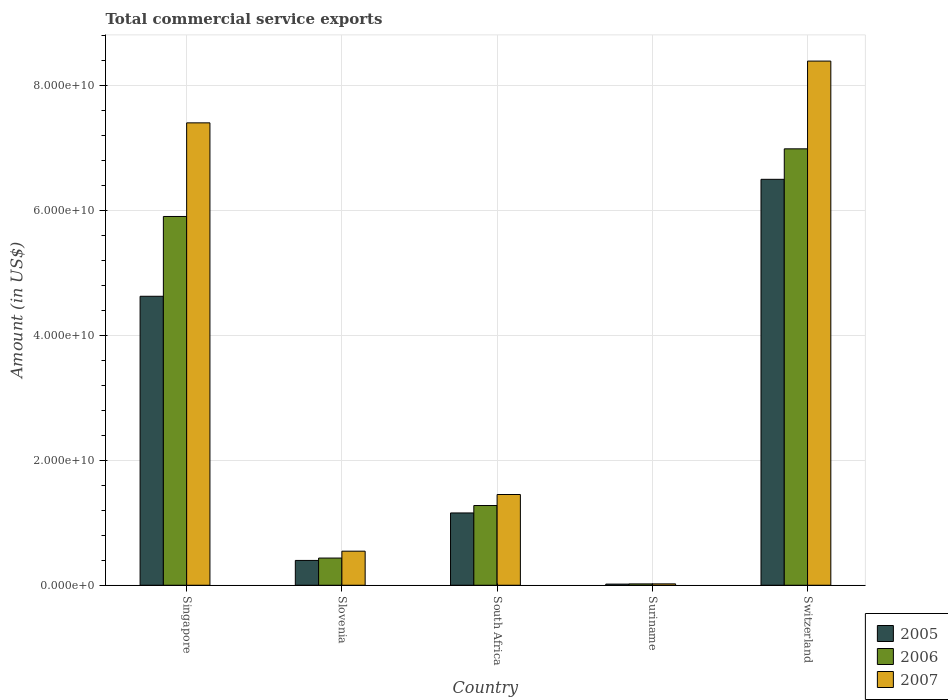How many different coloured bars are there?
Your response must be concise. 3. Are the number of bars per tick equal to the number of legend labels?
Keep it short and to the point. Yes. Are the number of bars on each tick of the X-axis equal?
Make the answer very short. Yes. How many bars are there on the 5th tick from the right?
Offer a terse response. 3. What is the label of the 3rd group of bars from the left?
Make the answer very short. South Africa. In how many cases, is the number of bars for a given country not equal to the number of legend labels?
Provide a succinct answer. 0. What is the total commercial service exports in 2006 in Singapore?
Give a very brief answer. 5.90e+1. Across all countries, what is the maximum total commercial service exports in 2006?
Keep it short and to the point. 6.98e+1. Across all countries, what is the minimum total commercial service exports in 2007?
Give a very brief answer. 2.19e+08. In which country was the total commercial service exports in 2007 maximum?
Provide a short and direct response. Switzerland. In which country was the total commercial service exports in 2007 minimum?
Give a very brief answer. Suriname. What is the total total commercial service exports in 2007 in the graph?
Offer a very short reply. 1.78e+11. What is the difference between the total commercial service exports in 2006 in Slovenia and that in Suriname?
Provide a short and direct response. 4.14e+09. What is the difference between the total commercial service exports in 2005 in Singapore and the total commercial service exports in 2006 in Suriname?
Give a very brief answer. 4.60e+1. What is the average total commercial service exports in 2006 per country?
Ensure brevity in your answer.  2.92e+1. What is the difference between the total commercial service exports of/in 2005 and total commercial service exports of/in 2007 in Suriname?
Make the answer very short. -3.61e+07. What is the ratio of the total commercial service exports in 2005 in Suriname to that in Switzerland?
Make the answer very short. 0. Is the total commercial service exports in 2006 in South Africa less than that in Suriname?
Provide a short and direct response. No. What is the difference between the highest and the second highest total commercial service exports in 2007?
Your answer should be compact. -6.94e+1. What is the difference between the highest and the lowest total commercial service exports in 2005?
Provide a succinct answer. 6.48e+1. In how many countries, is the total commercial service exports in 2007 greater than the average total commercial service exports in 2007 taken over all countries?
Offer a terse response. 2. Is it the case that in every country, the sum of the total commercial service exports in 2005 and total commercial service exports in 2007 is greater than the total commercial service exports in 2006?
Offer a very short reply. Yes. How many countries are there in the graph?
Ensure brevity in your answer.  5. Are the values on the major ticks of Y-axis written in scientific E-notation?
Offer a very short reply. Yes. Does the graph contain any zero values?
Your answer should be very brief. No. How are the legend labels stacked?
Offer a very short reply. Vertical. What is the title of the graph?
Keep it short and to the point. Total commercial service exports. Does "1998" appear as one of the legend labels in the graph?
Your answer should be very brief. No. What is the Amount (in US$) of 2005 in Singapore?
Ensure brevity in your answer.  4.62e+1. What is the Amount (in US$) of 2006 in Singapore?
Offer a terse response. 5.90e+1. What is the Amount (in US$) in 2007 in Singapore?
Your answer should be compact. 7.40e+1. What is the Amount (in US$) in 2005 in Slovenia?
Offer a very short reply. 3.97e+09. What is the Amount (in US$) in 2006 in Slovenia?
Provide a short and direct response. 4.35e+09. What is the Amount (in US$) of 2007 in Slovenia?
Your answer should be compact. 5.45e+09. What is the Amount (in US$) of 2005 in South Africa?
Ensure brevity in your answer.  1.16e+1. What is the Amount (in US$) in 2006 in South Africa?
Your response must be concise. 1.28e+1. What is the Amount (in US$) of 2007 in South Africa?
Your response must be concise. 1.45e+1. What is the Amount (in US$) in 2005 in Suriname?
Make the answer very short. 1.83e+08. What is the Amount (in US$) of 2006 in Suriname?
Provide a succinct answer. 2.14e+08. What is the Amount (in US$) in 2007 in Suriname?
Your response must be concise. 2.19e+08. What is the Amount (in US$) of 2005 in Switzerland?
Provide a short and direct response. 6.50e+1. What is the Amount (in US$) in 2006 in Switzerland?
Your answer should be compact. 6.98e+1. What is the Amount (in US$) in 2007 in Switzerland?
Provide a succinct answer. 8.39e+1. Across all countries, what is the maximum Amount (in US$) of 2005?
Provide a succinct answer. 6.50e+1. Across all countries, what is the maximum Amount (in US$) of 2006?
Your answer should be compact. 6.98e+1. Across all countries, what is the maximum Amount (in US$) in 2007?
Your answer should be very brief. 8.39e+1. Across all countries, what is the minimum Amount (in US$) in 2005?
Provide a short and direct response. 1.83e+08. Across all countries, what is the minimum Amount (in US$) of 2006?
Ensure brevity in your answer.  2.14e+08. Across all countries, what is the minimum Amount (in US$) in 2007?
Make the answer very short. 2.19e+08. What is the total Amount (in US$) of 2005 in the graph?
Offer a terse response. 1.27e+11. What is the total Amount (in US$) in 2006 in the graph?
Provide a short and direct response. 1.46e+11. What is the total Amount (in US$) of 2007 in the graph?
Offer a very short reply. 1.78e+11. What is the difference between the Amount (in US$) of 2005 in Singapore and that in Slovenia?
Your answer should be very brief. 4.23e+1. What is the difference between the Amount (in US$) of 2006 in Singapore and that in Slovenia?
Offer a very short reply. 5.47e+1. What is the difference between the Amount (in US$) in 2007 in Singapore and that in Slovenia?
Provide a short and direct response. 6.85e+1. What is the difference between the Amount (in US$) in 2005 in Singapore and that in South Africa?
Your answer should be compact. 3.47e+1. What is the difference between the Amount (in US$) of 2006 in Singapore and that in South Africa?
Make the answer very short. 4.63e+1. What is the difference between the Amount (in US$) of 2007 in Singapore and that in South Africa?
Keep it short and to the point. 5.95e+1. What is the difference between the Amount (in US$) of 2005 in Singapore and that in Suriname?
Offer a terse response. 4.61e+1. What is the difference between the Amount (in US$) of 2006 in Singapore and that in Suriname?
Offer a terse response. 5.88e+1. What is the difference between the Amount (in US$) in 2007 in Singapore and that in Suriname?
Provide a succinct answer. 7.38e+1. What is the difference between the Amount (in US$) of 2005 in Singapore and that in Switzerland?
Your answer should be compact. -1.87e+1. What is the difference between the Amount (in US$) of 2006 in Singapore and that in Switzerland?
Your answer should be compact. -1.08e+1. What is the difference between the Amount (in US$) of 2007 in Singapore and that in Switzerland?
Your response must be concise. -9.89e+09. What is the difference between the Amount (in US$) of 2005 in Slovenia and that in South Africa?
Make the answer very short. -7.60e+09. What is the difference between the Amount (in US$) of 2006 in Slovenia and that in South Africa?
Your answer should be compact. -8.41e+09. What is the difference between the Amount (in US$) in 2007 in Slovenia and that in South Africa?
Make the answer very short. -9.07e+09. What is the difference between the Amount (in US$) of 2005 in Slovenia and that in Suriname?
Your response must be concise. 3.79e+09. What is the difference between the Amount (in US$) in 2006 in Slovenia and that in Suriname?
Provide a succinct answer. 4.14e+09. What is the difference between the Amount (in US$) in 2007 in Slovenia and that in Suriname?
Give a very brief answer. 5.23e+09. What is the difference between the Amount (in US$) in 2005 in Slovenia and that in Switzerland?
Your response must be concise. -6.10e+1. What is the difference between the Amount (in US$) of 2006 in Slovenia and that in Switzerland?
Offer a very short reply. -6.55e+1. What is the difference between the Amount (in US$) of 2007 in Slovenia and that in Switzerland?
Make the answer very short. -7.84e+1. What is the difference between the Amount (in US$) of 2005 in South Africa and that in Suriname?
Give a very brief answer. 1.14e+1. What is the difference between the Amount (in US$) of 2006 in South Africa and that in Suriname?
Give a very brief answer. 1.25e+1. What is the difference between the Amount (in US$) in 2007 in South Africa and that in Suriname?
Keep it short and to the point. 1.43e+1. What is the difference between the Amount (in US$) in 2005 in South Africa and that in Switzerland?
Make the answer very short. -5.34e+1. What is the difference between the Amount (in US$) in 2006 in South Africa and that in Switzerland?
Ensure brevity in your answer.  -5.71e+1. What is the difference between the Amount (in US$) in 2007 in South Africa and that in Switzerland?
Your response must be concise. -6.94e+1. What is the difference between the Amount (in US$) in 2005 in Suriname and that in Switzerland?
Offer a very short reply. -6.48e+1. What is the difference between the Amount (in US$) of 2006 in Suriname and that in Switzerland?
Your response must be concise. -6.96e+1. What is the difference between the Amount (in US$) of 2007 in Suriname and that in Switzerland?
Give a very brief answer. -8.37e+1. What is the difference between the Amount (in US$) in 2005 in Singapore and the Amount (in US$) in 2006 in Slovenia?
Your response must be concise. 4.19e+1. What is the difference between the Amount (in US$) in 2005 in Singapore and the Amount (in US$) in 2007 in Slovenia?
Offer a terse response. 4.08e+1. What is the difference between the Amount (in US$) in 2006 in Singapore and the Amount (in US$) in 2007 in Slovenia?
Make the answer very short. 5.36e+1. What is the difference between the Amount (in US$) in 2005 in Singapore and the Amount (in US$) in 2006 in South Africa?
Ensure brevity in your answer.  3.35e+1. What is the difference between the Amount (in US$) in 2005 in Singapore and the Amount (in US$) in 2007 in South Africa?
Keep it short and to the point. 3.17e+1. What is the difference between the Amount (in US$) in 2006 in Singapore and the Amount (in US$) in 2007 in South Africa?
Give a very brief answer. 4.45e+1. What is the difference between the Amount (in US$) in 2005 in Singapore and the Amount (in US$) in 2006 in Suriname?
Make the answer very short. 4.60e+1. What is the difference between the Amount (in US$) in 2005 in Singapore and the Amount (in US$) in 2007 in Suriname?
Your answer should be compact. 4.60e+1. What is the difference between the Amount (in US$) of 2006 in Singapore and the Amount (in US$) of 2007 in Suriname?
Give a very brief answer. 5.88e+1. What is the difference between the Amount (in US$) in 2005 in Singapore and the Amount (in US$) in 2006 in Switzerland?
Your answer should be compact. -2.36e+1. What is the difference between the Amount (in US$) in 2005 in Singapore and the Amount (in US$) in 2007 in Switzerland?
Your response must be concise. -3.76e+1. What is the difference between the Amount (in US$) of 2006 in Singapore and the Amount (in US$) of 2007 in Switzerland?
Your answer should be very brief. -2.49e+1. What is the difference between the Amount (in US$) in 2005 in Slovenia and the Amount (in US$) in 2006 in South Africa?
Your response must be concise. -8.79e+09. What is the difference between the Amount (in US$) in 2005 in Slovenia and the Amount (in US$) in 2007 in South Africa?
Provide a short and direct response. -1.05e+1. What is the difference between the Amount (in US$) in 2006 in Slovenia and the Amount (in US$) in 2007 in South Africa?
Provide a succinct answer. -1.02e+1. What is the difference between the Amount (in US$) of 2005 in Slovenia and the Amount (in US$) of 2006 in Suriname?
Your answer should be compact. 3.76e+09. What is the difference between the Amount (in US$) in 2005 in Slovenia and the Amount (in US$) in 2007 in Suriname?
Make the answer very short. 3.75e+09. What is the difference between the Amount (in US$) of 2006 in Slovenia and the Amount (in US$) of 2007 in Suriname?
Make the answer very short. 4.13e+09. What is the difference between the Amount (in US$) in 2005 in Slovenia and the Amount (in US$) in 2006 in Switzerland?
Your answer should be compact. -6.59e+1. What is the difference between the Amount (in US$) of 2005 in Slovenia and the Amount (in US$) of 2007 in Switzerland?
Your answer should be compact. -7.99e+1. What is the difference between the Amount (in US$) in 2006 in Slovenia and the Amount (in US$) in 2007 in Switzerland?
Keep it short and to the point. -7.95e+1. What is the difference between the Amount (in US$) of 2005 in South Africa and the Amount (in US$) of 2006 in Suriname?
Make the answer very short. 1.14e+1. What is the difference between the Amount (in US$) in 2005 in South Africa and the Amount (in US$) in 2007 in Suriname?
Your response must be concise. 1.14e+1. What is the difference between the Amount (in US$) of 2006 in South Africa and the Amount (in US$) of 2007 in Suriname?
Make the answer very short. 1.25e+1. What is the difference between the Amount (in US$) in 2005 in South Africa and the Amount (in US$) in 2006 in Switzerland?
Your answer should be compact. -5.83e+1. What is the difference between the Amount (in US$) in 2005 in South Africa and the Amount (in US$) in 2007 in Switzerland?
Your answer should be very brief. -7.23e+1. What is the difference between the Amount (in US$) in 2006 in South Africa and the Amount (in US$) in 2007 in Switzerland?
Offer a very short reply. -7.11e+1. What is the difference between the Amount (in US$) of 2005 in Suriname and the Amount (in US$) of 2006 in Switzerland?
Your answer should be compact. -6.97e+1. What is the difference between the Amount (in US$) of 2005 in Suriname and the Amount (in US$) of 2007 in Switzerland?
Your response must be concise. -8.37e+1. What is the difference between the Amount (in US$) of 2006 in Suriname and the Amount (in US$) of 2007 in Switzerland?
Offer a terse response. -8.37e+1. What is the average Amount (in US$) in 2005 per country?
Your answer should be compact. 2.54e+1. What is the average Amount (in US$) in 2006 per country?
Make the answer very short. 2.92e+1. What is the average Amount (in US$) in 2007 per country?
Keep it short and to the point. 3.56e+1. What is the difference between the Amount (in US$) of 2005 and Amount (in US$) of 2006 in Singapore?
Offer a terse response. -1.28e+1. What is the difference between the Amount (in US$) of 2005 and Amount (in US$) of 2007 in Singapore?
Your answer should be compact. -2.78e+1. What is the difference between the Amount (in US$) of 2006 and Amount (in US$) of 2007 in Singapore?
Keep it short and to the point. -1.50e+1. What is the difference between the Amount (in US$) in 2005 and Amount (in US$) in 2006 in Slovenia?
Your response must be concise. -3.80e+08. What is the difference between the Amount (in US$) of 2005 and Amount (in US$) of 2007 in Slovenia?
Offer a very short reply. -1.48e+09. What is the difference between the Amount (in US$) of 2006 and Amount (in US$) of 2007 in Slovenia?
Give a very brief answer. -1.10e+09. What is the difference between the Amount (in US$) of 2005 and Amount (in US$) of 2006 in South Africa?
Make the answer very short. -1.19e+09. What is the difference between the Amount (in US$) of 2005 and Amount (in US$) of 2007 in South Africa?
Offer a very short reply. -2.95e+09. What is the difference between the Amount (in US$) in 2006 and Amount (in US$) in 2007 in South Africa?
Your response must be concise. -1.76e+09. What is the difference between the Amount (in US$) in 2005 and Amount (in US$) in 2006 in Suriname?
Give a very brief answer. -3.10e+07. What is the difference between the Amount (in US$) of 2005 and Amount (in US$) of 2007 in Suriname?
Provide a succinct answer. -3.61e+07. What is the difference between the Amount (in US$) of 2006 and Amount (in US$) of 2007 in Suriname?
Your answer should be compact. -5.10e+06. What is the difference between the Amount (in US$) in 2005 and Amount (in US$) in 2006 in Switzerland?
Make the answer very short. -4.88e+09. What is the difference between the Amount (in US$) in 2005 and Amount (in US$) in 2007 in Switzerland?
Keep it short and to the point. -1.89e+1. What is the difference between the Amount (in US$) in 2006 and Amount (in US$) in 2007 in Switzerland?
Offer a very short reply. -1.40e+1. What is the ratio of the Amount (in US$) in 2005 in Singapore to that in Slovenia?
Make the answer very short. 11.65. What is the ratio of the Amount (in US$) of 2006 in Singapore to that in Slovenia?
Offer a terse response. 13.57. What is the ratio of the Amount (in US$) of 2007 in Singapore to that in Slovenia?
Offer a very short reply. 13.58. What is the ratio of the Amount (in US$) in 2005 in Singapore to that in South Africa?
Your answer should be compact. 4. What is the ratio of the Amount (in US$) of 2006 in Singapore to that in South Africa?
Your answer should be compact. 4.63. What is the ratio of the Amount (in US$) in 2007 in Singapore to that in South Africa?
Your answer should be very brief. 5.1. What is the ratio of the Amount (in US$) of 2005 in Singapore to that in Suriname?
Provide a short and direct response. 253.25. What is the ratio of the Amount (in US$) in 2006 in Singapore to that in Suriname?
Offer a very short reply. 276.28. What is the ratio of the Amount (in US$) of 2007 in Singapore to that in Suriname?
Offer a terse response. 338.34. What is the ratio of the Amount (in US$) of 2005 in Singapore to that in Switzerland?
Offer a very short reply. 0.71. What is the ratio of the Amount (in US$) of 2006 in Singapore to that in Switzerland?
Offer a very short reply. 0.84. What is the ratio of the Amount (in US$) of 2007 in Singapore to that in Switzerland?
Your answer should be compact. 0.88. What is the ratio of the Amount (in US$) of 2005 in Slovenia to that in South Africa?
Keep it short and to the point. 0.34. What is the ratio of the Amount (in US$) of 2006 in Slovenia to that in South Africa?
Offer a very short reply. 0.34. What is the ratio of the Amount (in US$) in 2007 in Slovenia to that in South Africa?
Your answer should be very brief. 0.38. What is the ratio of the Amount (in US$) in 2005 in Slovenia to that in Suriname?
Keep it short and to the point. 21.74. What is the ratio of the Amount (in US$) in 2006 in Slovenia to that in Suriname?
Offer a terse response. 20.36. What is the ratio of the Amount (in US$) of 2007 in Slovenia to that in Suriname?
Your response must be concise. 24.92. What is the ratio of the Amount (in US$) in 2005 in Slovenia to that in Switzerland?
Provide a short and direct response. 0.06. What is the ratio of the Amount (in US$) of 2006 in Slovenia to that in Switzerland?
Provide a succinct answer. 0.06. What is the ratio of the Amount (in US$) in 2007 in Slovenia to that in Switzerland?
Provide a short and direct response. 0.07. What is the ratio of the Amount (in US$) in 2005 in South Africa to that in Suriname?
Offer a terse response. 63.36. What is the ratio of the Amount (in US$) of 2006 in South Africa to that in Suriname?
Give a very brief answer. 59.72. What is the ratio of the Amount (in US$) in 2007 in South Africa to that in Suriname?
Your answer should be very brief. 66.39. What is the ratio of the Amount (in US$) in 2005 in South Africa to that in Switzerland?
Your answer should be compact. 0.18. What is the ratio of the Amount (in US$) of 2006 in South Africa to that in Switzerland?
Offer a terse response. 0.18. What is the ratio of the Amount (in US$) of 2007 in South Africa to that in Switzerland?
Keep it short and to the point. 0.17. What is the ratio of the Amount (in US$) in 2005 in Suriname to that in Switzerland?
Your response must be concise. 0. What is the ratio of the Amount (in US$) of 2006 in Suriname to that in Switzerland?
Provide a short and direct response. 0. What is the ratio of the Amount (in US$) in 2007 in Suriname to that in Switzerland?
Ensure brevity in your answer.  0. What is the difference between the highest and the second highest Amount (in US$) of 2005?
Your response must be concise. 1.87e+1. What is the difference between the highest and the second highest Amount (in US$) of 2006?
Ensure brevity in your answer.  1.08e+1. What is the difference between the highest and the second highest Amount (in US$) of 2007?
Offer a very short reply. 9.89e+09. What is the difference between the highest and the lowest Amount (in US$) in 2005?
Your answer should be very brief. 6.48e+1. What is the difference between the highest and the lowest Amount (in US$) of 2006?
Provide a succinct answer. 6.96e+1. What is the difference between the highest and the lowest Amount (in US$) in 2007?
Offer a very short reply. 8.37e+1. 